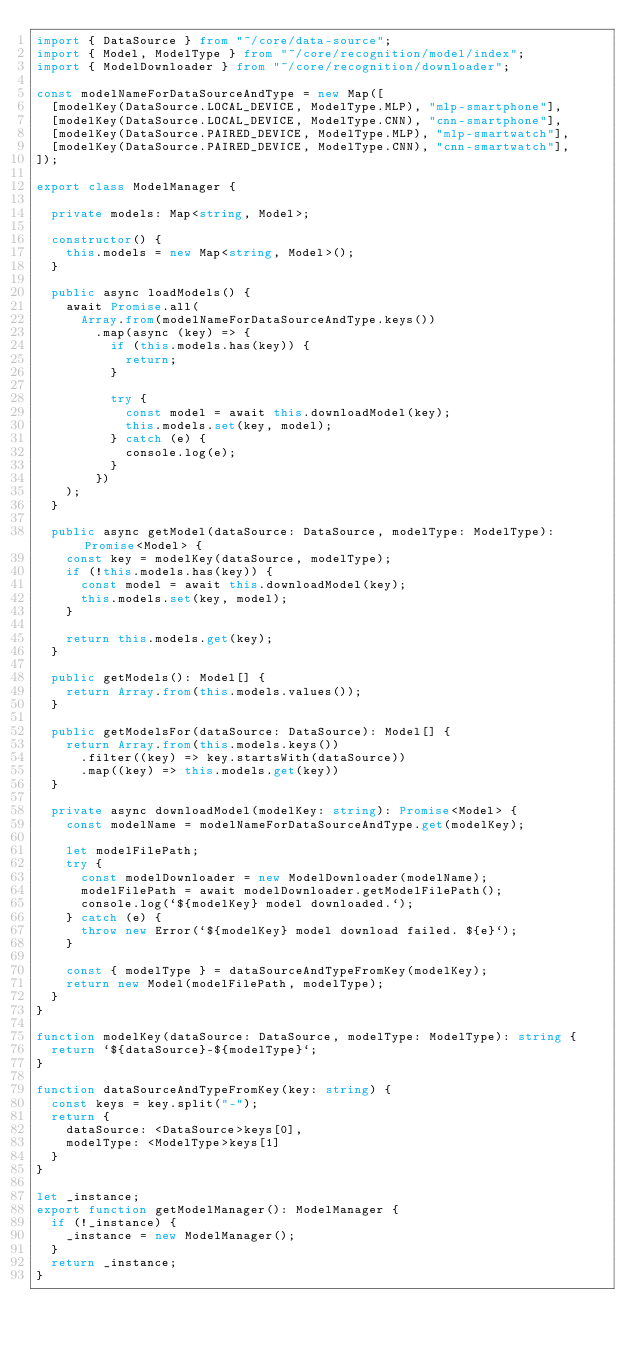<code> <loc_0><loc_0><loc_500><loc_500><_TypeScript_>import { DataSource } from "~/core/data-source";
import { Model, ModelType } from "~/core/recognition/model/index";
import { ModelDownloader } from "~/core/recognition/downloader";

const modelNameForDataSourceAndType = new Map([
  [modelKey(DataSource.LOCAL_DEVICE, ModelType.MLP), "mlp-smartphone"],
  [modelKey(DataSource.LOCAL_DEVICE, ModelType.CNN), "cnn-smartphone"],
  [modelKey(DataSource.PAIRED_DEVICE, ModelType.MLP), "mlp-smartwatch"],
  [modelKey(DataSource.PAIRED_DEVICE, ModelType.CNN), "cnn-smartwatch"],
]);

export class ModelManager {

  private models: Map<string, Model>;

  constructor() {
    this.models = new Map<string, Model>();
  }

  public async loadModels() {
    await Promise.all(
      Array.from(modelNameForDataSourceAndType.keys())
        .map(async (key) => {
          if (this.models.has(key)) {
            return;
          }

          try {
            const model = await this.downloadModel(key);
            this.models.set(key, model);
          } catch (e) {
            console.log(e);
          }
        })
    );
  }

  public async getModel(dataSource: DataSource, modelType: ModelType): Promise<Model> {
    const key = modelKey(dataSource, modelType);
    if (!this.models.has(key)) {
      const model = await this.downloadModel(key);
      this.models.set(key, model);
    }

    return this.models.get(key);
  }

  public getModels(): Model[] {
    return Array.from(this.models.values());
  }

  public getModelsFor(dataSource: DataSource): Model[] {
    return Array.from(this.models.keys())
      .filter((key) => key.startsWith(dataSource))
      .map((key) => this.models.get(key))
  }

  private async downloadModel(modelKey: string): Promise<Model> {
    const modelName = modelNameForDataSourceAndType.get(modelKey);

    let modelFilePath;
    try {
      const modelDownloader = new ModelDownloader(modelName);
      modelFilePath = await modelDownloader.getModelFilePath();
      console.log(`${modelKey} model downloaded.`);
    } catch (e) {
      throw new Error(`${modelKey} model download failed. ${e}`);
    }

    const { modelType } = dataSourceAndTypeFromKey(modelKey);
    return new Model(modelFilePath, modelType);
  }
}

function modelKey(dataSource: DataSource, modelType: ModelType): string {
  return `${dataSource}-${modelType}`;
}

function dataSourceAndTypeFromKey(key: string) {
  const keys = key.split("-");
  return {
    dataSource: <DataSource>keys[0],
    modelType: <ModelType>keys[1]
  }
}

let _instance;
export function getModelManager(): ModelManager {
  if (!_instance) {
    _instance = new ModelManager();
  }
  return _instance;
}
</code> 